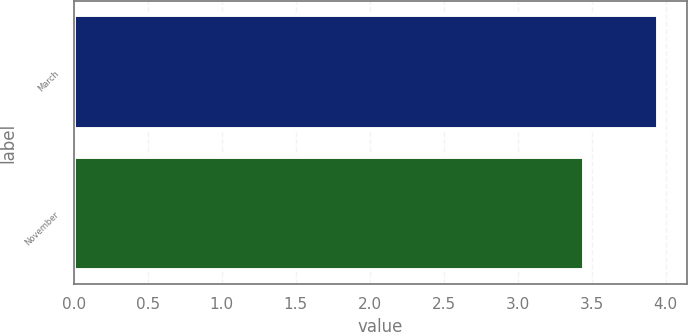Convert chart to OTSL. <chart><loc_0><loc_0><loc_500><loc_500><bar_chart><fcel>March<fcel>November<nl><fcel>3.95<fcel>3.45<nl></chart> 